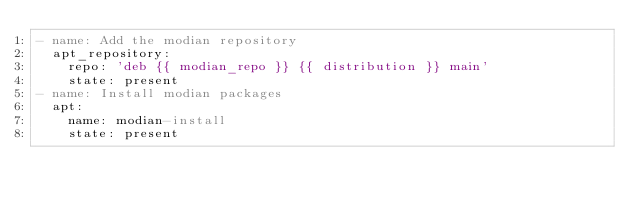<code> <loc_0><loc_0><loc_500><loc_500><_YAML_>- name: Add the modian repository
  apt_repository:
    repo: 'deb {{ modian_repo }} {{ distribution }} main'
    state: present
- name: Install modian packages
  apt:
    name: modian-install
    state: present
</code> 